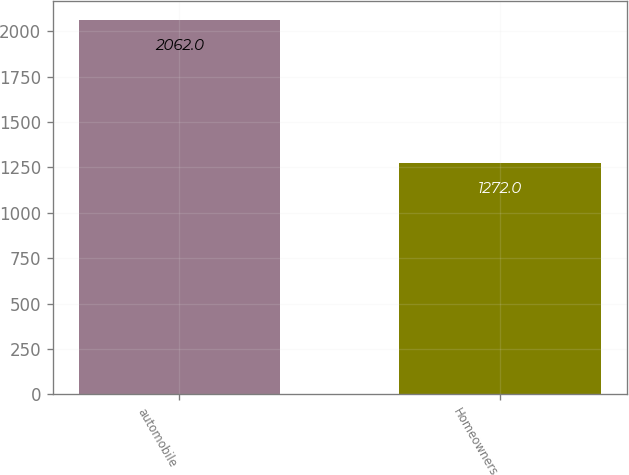Convert chart to OTSL. <chart><loc_0><loc_0><loc_500><loc_500><bar_chart><fcel>automobile<fcel>Homeowners<nl><fcel>2062<fcel>1272<nl></chart> 